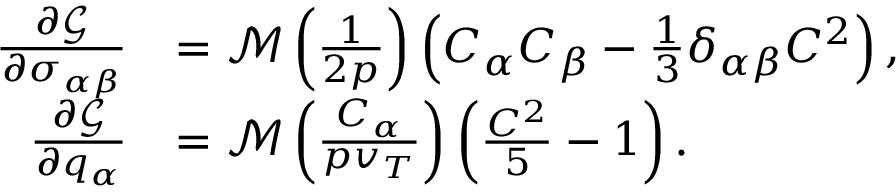<formula> <loc_0><loc_0><loc_500><loc_500>\begin{array} { r l } { \frac { \partial \mathcal { G } } { \partial \sigma _ { \alpha \beta } } } & { = \mathcal { M } \left ( \frac { 1 } { 2 p } \right ) \left ( C _ { \alpha } C _ { \beta } - \frac { 1 } { 3 } \delta _ { \alpha \beta } C ^ { 2 } \right ) , } \\ { \frac { \partial \mathcal { G } } { \partial q _ { \alpha } } } & { = \mathcal { M } \left ( \frac { C _ { \alpha } } { p v _ { T } } \right ) \left ( \frac { C ^ { 2 } } { 5 } - 1 \right ) . } \end{array}</formula> 